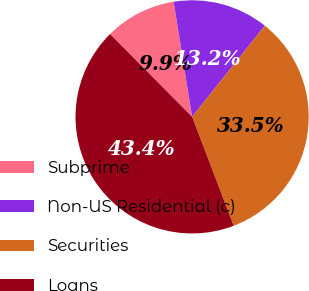<chart> <loc_0><loc_0><loc_500><loc_500><pie_chart><fcel>Subprime<fcel>Non-US Residential (c)<fcel>Securities<fcel>Loans<nl><fcel>9.9%<fcel>13.25%<fcel>33.48%<fcel>43.38%<nl></chart> 